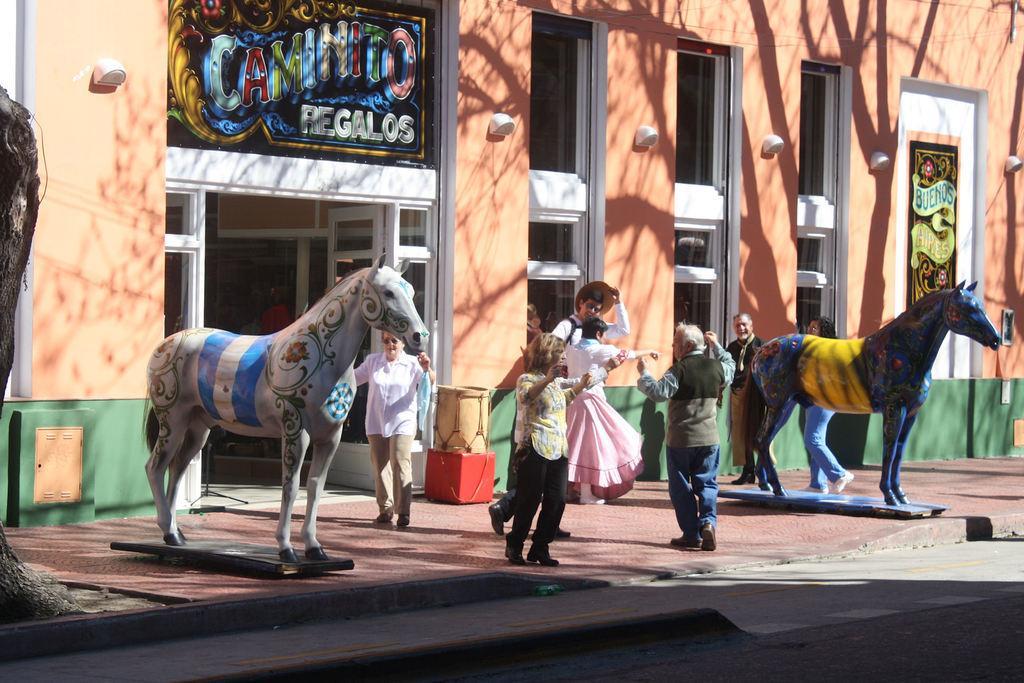Can you describe this image briefly? In this image there are group of people standing , horse sculptures, building, tabla. 